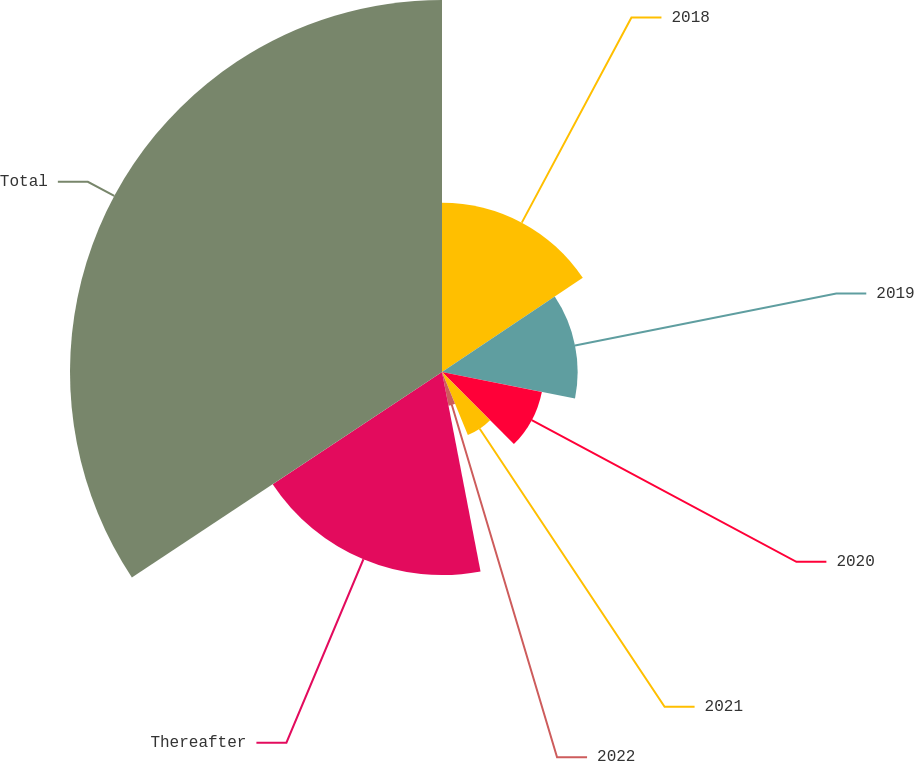Convert chart. <chart><loc_0><loc_0><loc_500><loc_500><pie_chart><fcel>2018<fcel>2019<fcel>2020<fcel>2021<fcel>2022<fcel>Thereafter<fcel>Total<nl><fcel>15.62%<fcel>12.51%<fcel>9.39%<fcel>6.28%<fcel>3.16%<fcel>18.73%<fcel>34.31%<nl></chart> 